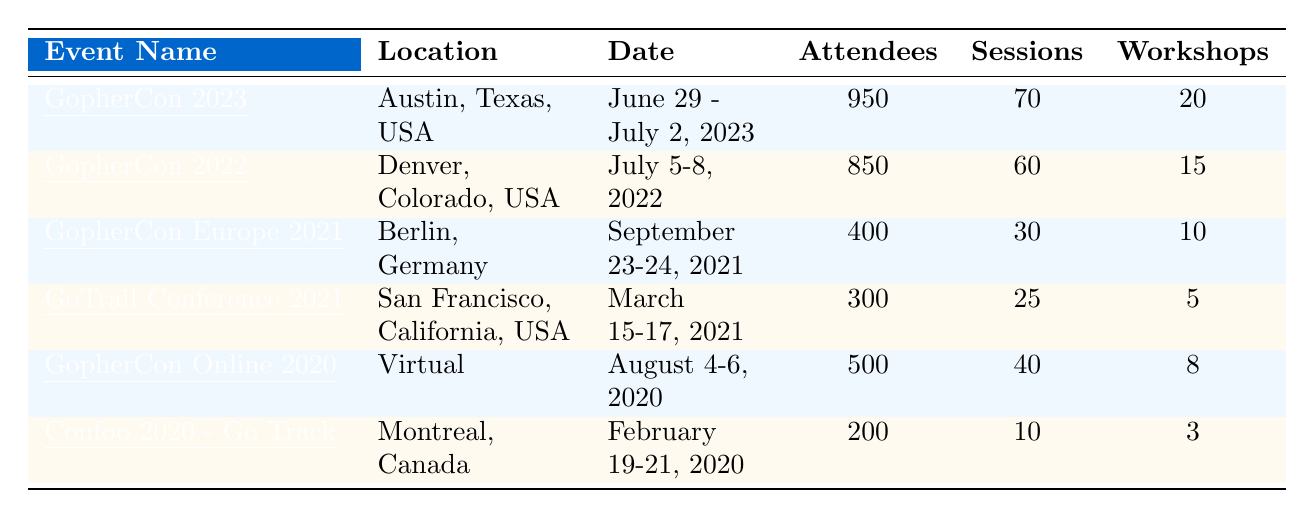What is the location of GopherCon 2022? The table lists the location for GopherCon 2022 in the second row under the "Location" column, which shows "Denver, Colorado, USA."
Answer: Denver, Colorado, USA How many attendees were present at GopherCon 2023? The table indicates the number of attendees for GopherCon 2023 in the first row under the "Attendees" column, which states "950."
Answer: 950 What was the total number of attendees for GopherCon 2022 and GopherCon 2023 combined? The number of attendees for GopherCon 2022 is 850, and for GopherCon 2023, it is 950. Adding these gives 850 + 950 = 1800.
Answer: 1800 Which event had the fewest number of workshops? By examining the "Workshops" column, Confoo 2020 - Go Track has the lowest value with "3."
Answer: Confoo 2020 - Go Track How many total sessions were held across all events listed? The table shows the number of sessions for each event. Summing these values gives: 70 (GopherCon 2023) + 60 (GopherCon 2022) + 30 (GopherCon Europe 2021) + 25 (GoTrail Conference 2021) + 40 (GopherCon Online 2020) + 10 (Confoo 2020) = 235.
Answer: 235 Did GopherCon Online 2020 have more attendees than GoTrail Conference 2021? GopherCon Online 2020 had 500 attendees, while GoTrail Conference 2021 only had 300 attendees. Since 500 > 300, the answer is yes.
Answer: Yes What is the difference in the number of workshops between GopherCon 2023 and GopherCon 2022? GopherCon 2023 had 20 workshops, and GopherCon 2022 had 15 workshops. The difference is 20 - 15 = 5.
Answer: 5 What was the average number of attendees across all events? The total number of attendees is 850 + 400 + 950 + 300 + 500 + 200 = 3200. There are 6 events, therefore the average is 3200 / 6 = 533.33, which rounds to 533 when expressed as a whole number.
Answer: 533 Which event had the most sessions and how many were there? Checking the "Sessions" column shows GopherCon 2023 had the highest with 70 sessions.
Answer: GopherCon 2023, 70 sessions How many workshops were conducted in total during GopherCon events from 2020 to 2023? The workshops were as follows: GopherCon 2023 had 20, GopherCon 2022 had 15, GopherCon Online 2020 had 8, and GopherCon Europe 2021 had 10. Summing these gives 20 + 15 + 8 + 10 = 53.
Answer: 53 